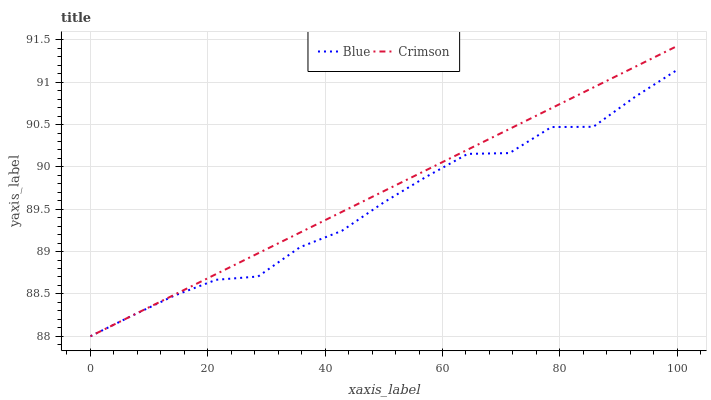Does Blue have the minimum area under the curve?
Answer yes or no. Yes. Does Crimson have the maximum area under the curve?
Answer yes or no. Yes. Does Crimson have the minimum area under the curve?
Answer yes or no. No. Is Crimson the smoothest?
Answer yes or no. Yes. Is Blue the roughest?
Answer yes or no. Yes. Is Crimson the roughest?
Answer yes or no. No. Does Crimson have the highest value?
Answer yes or no. Yes. Does Crimson intersect Blue?
Answer yes or no. Yes. Is Crimson less than Blue?
Answer yes or no. No. Is Crimson greater than Blue?
Answer yes or no. No. 